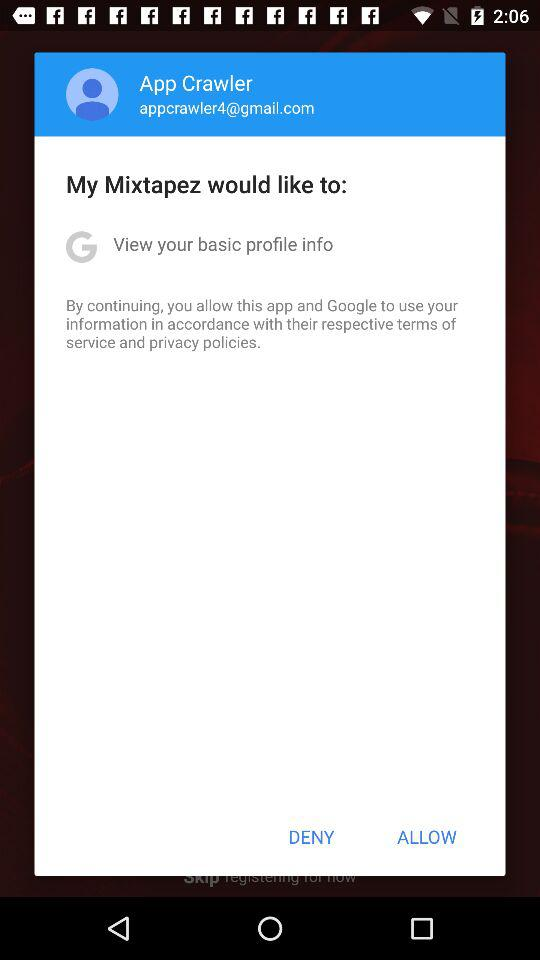What is the user name? The user name is App Crawler. 